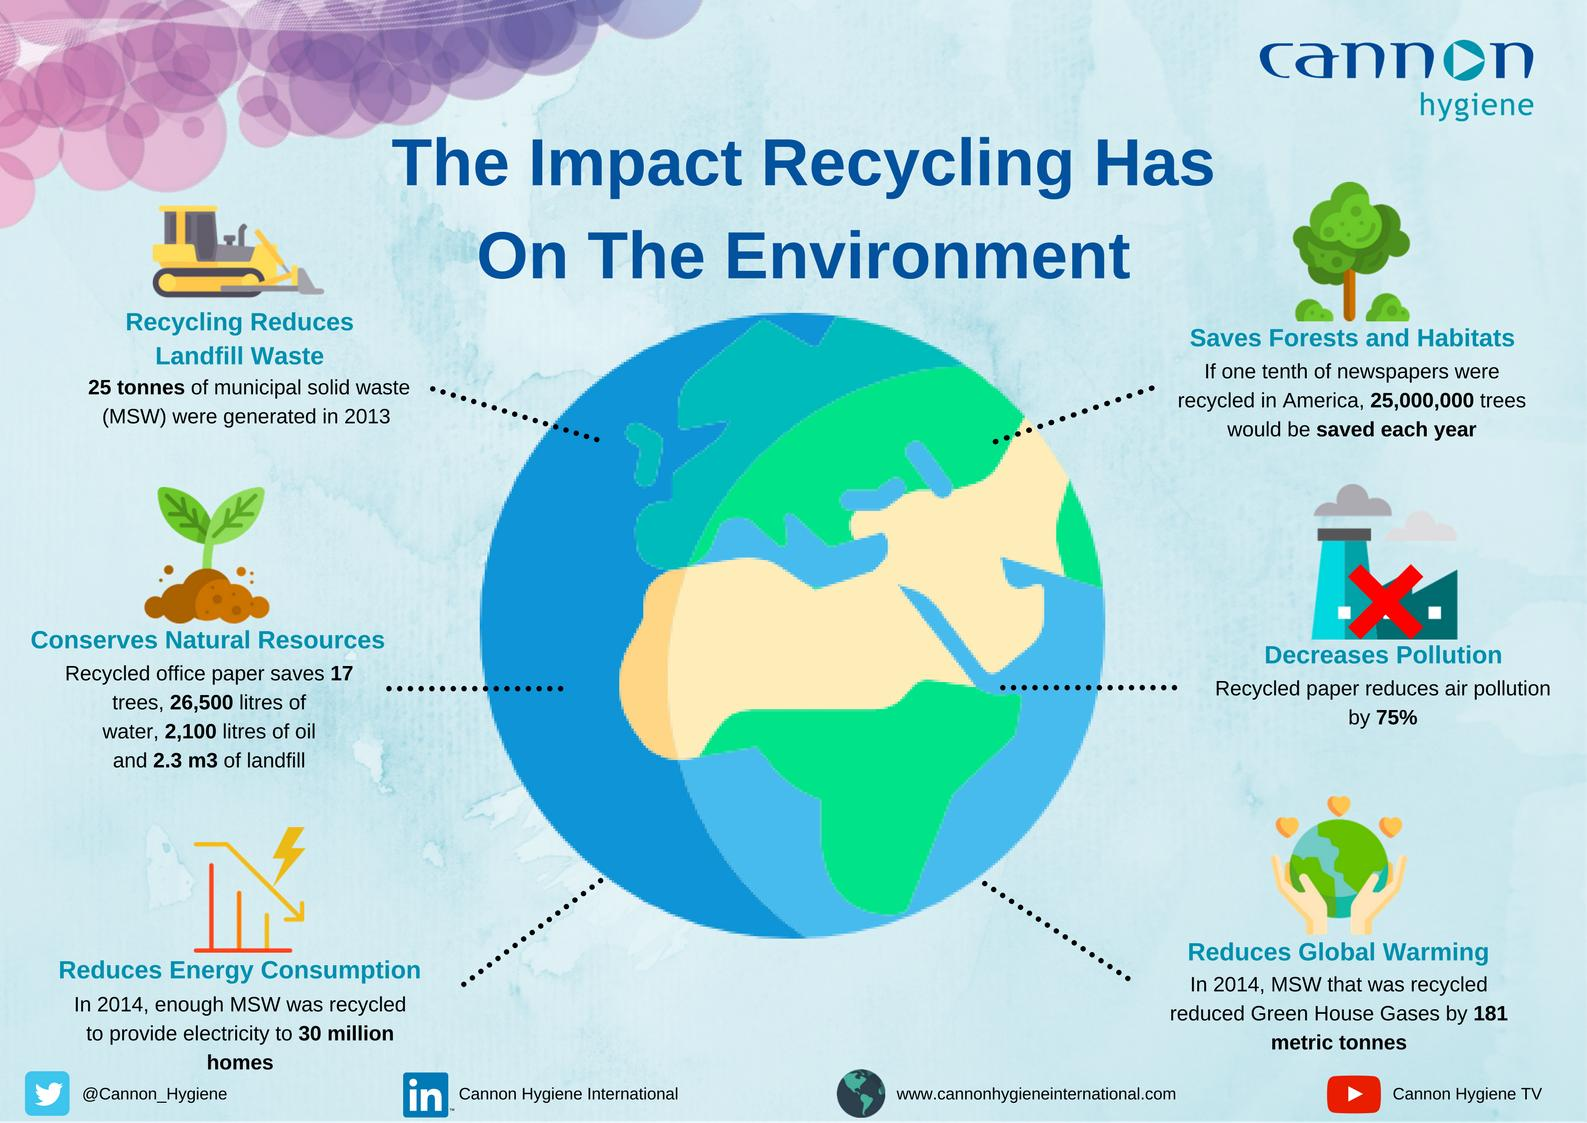Give some essential details in this illustration. The use of recycled papers leads to a 75% reduction in air pollution compared to the use of non-recycled papers. If one-tenth of newspapers in America were recycled, approximately 25,000,000 trees would be saved each year. In 2014, the recycling of municipal solid waste resulted in a reduction of 181 metric tons of greenhouse gases. 